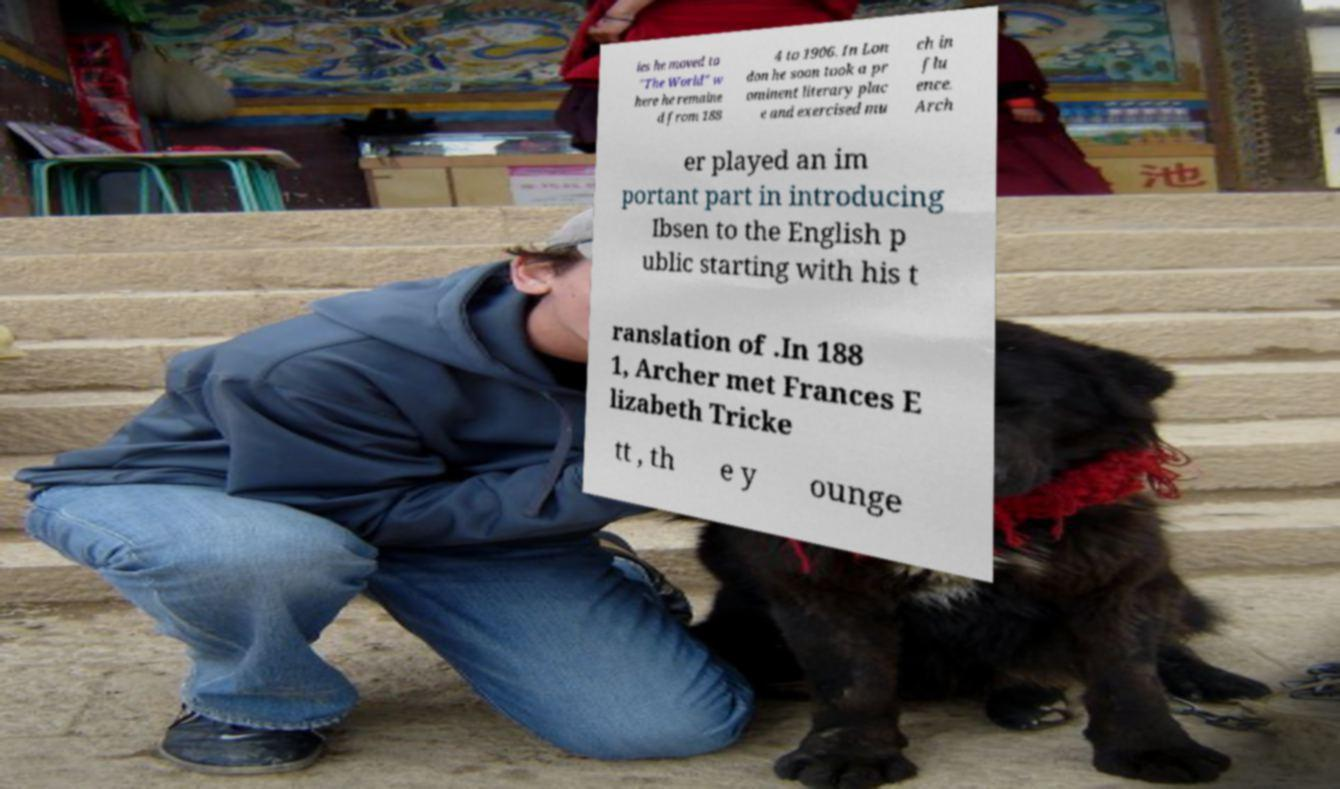Please read and relay the text visible in this image. What does it say? ies he moved to "The World" w here he remaine d from 188 4 to 1906. In Lon don he soon took a pr ominent literary plac e and exercised mu ch in flu ence. Arch er played an im portant part in introducing Ibsen to the English p ublic starting with his t ranslation of .In 188 1, Archer met Frances E lizabeth Tricke tt , th e y ounge 